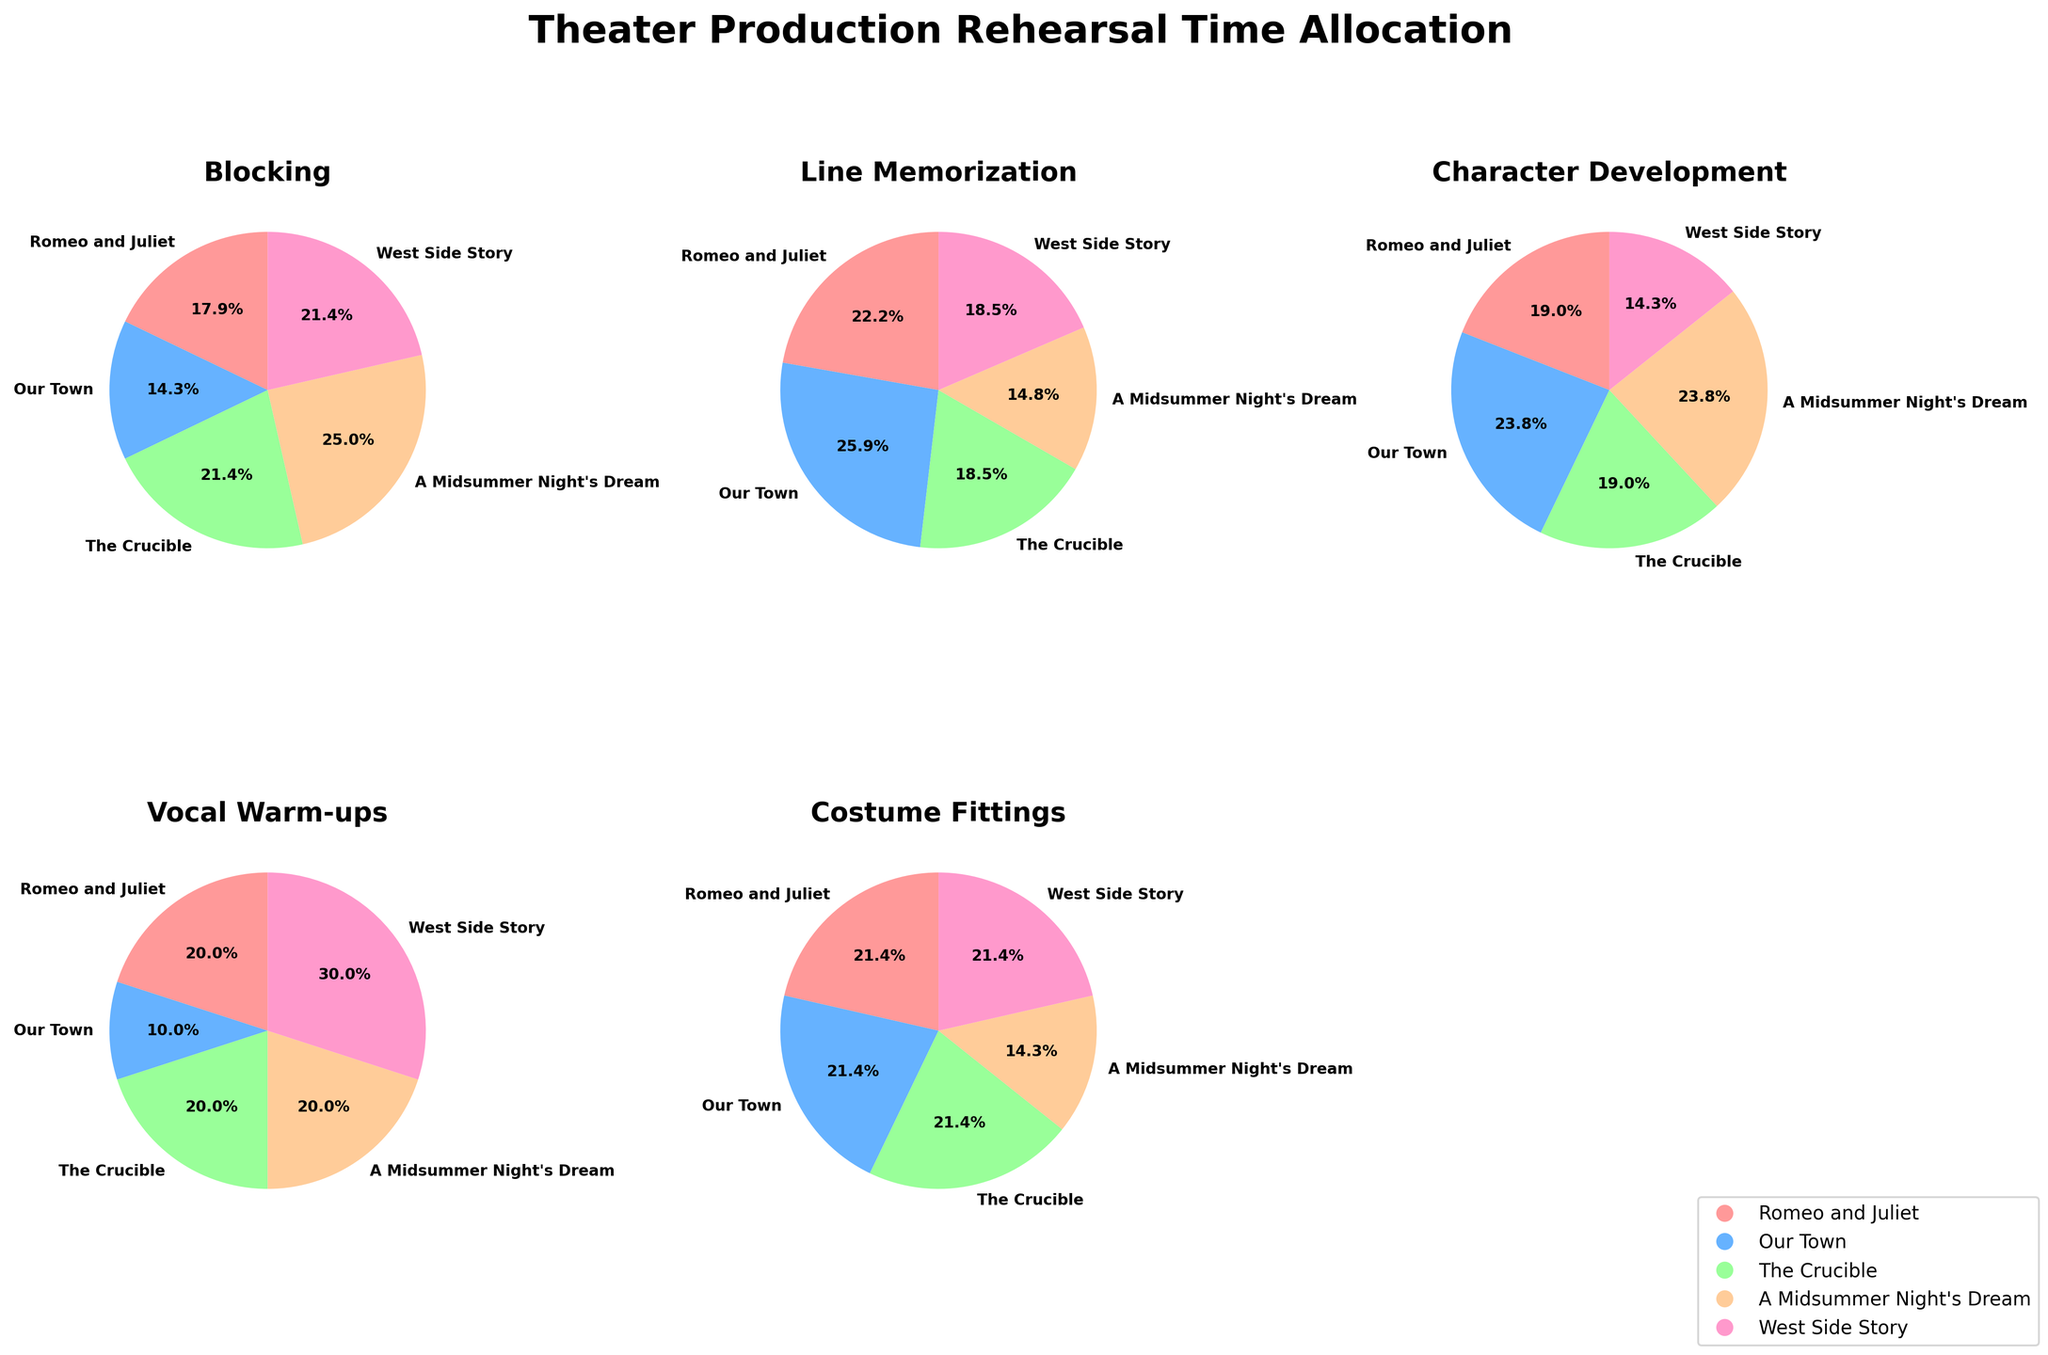What's the title of the figure? The title is prominently displayed at the top of the figure. It helps in understanding the overall theme of the visual representation.
Answer: Theater Production Rehearsal Time Allocation How many subplots are present in the figure? By observing the figure, you can count the individual pie charts. Each subplot represents a different aspect of the rehearsal time allocation. There are also blank spaces for unused subplots.
Answer: 5 Which aspect has the largest rehearsal time allocation in "A Midsummer Night's Dream"? Look at the pie chart corresponding to the "A Midsummer Night's Dream" and identify the slice with the largest area. This represents the aspect with the largest allocation.
Answer: Blocking Comparing "Romeo and Juliet" and "West Side Story," which play has more rehearsal time allocated to Vocal Warm-ups? Examine the Vocal Warm-ups subplot and compare the slices for "Romeo and Juliet" and "West Side Story." The larger slice indicates more rehearsal time.
Answer: West Side Story Which play has the smallest slice in the Line Memorization subplot? Identify the Line Memorization subplot and compare the size of the slices. The smallest slice represents the play with the least time allocated to Line Memorization.
Answer: A Midsummer Night's Dream How is the rehearsal time for Costume Fittings distributed across the plays? Look at the pie chart for Costume Fittings and refer to the legend. Note the relative slice sizes representing each play.
Answer: Equal among Romeo and Juliet, Our Town, The Crucible, and West Side Story; least for A Midsummer Night's Dream Which play has the highest average rehearsal time allocation across all aspects? Calculate the average by summing the rehearsal times for each play and dividing by the number of aspects (5). Compare the averages.
Answer: Our Town Which aspect has the most evenly distributed rehearsal time allocation among all plays? Examine all subplots and determine which one has slices of approximately equal size, indicating even distribution.
Answer: Costume Fittings Comparing the Blocking aspect, which play has allocated the least amount of time? Look at the Blocking subplot and find the smallest slice by referring to the legend.
Answer: Our Town How does the rehearsal time for Character Development differ between "Romeo and Juliet" and "West Side Story"? Compare the slices for these two plays in the Character Development subplot. Note the relative sizes to determine if they are smaller, larger, or equal.
Answer: Romeo and Juliet > West Side Story 